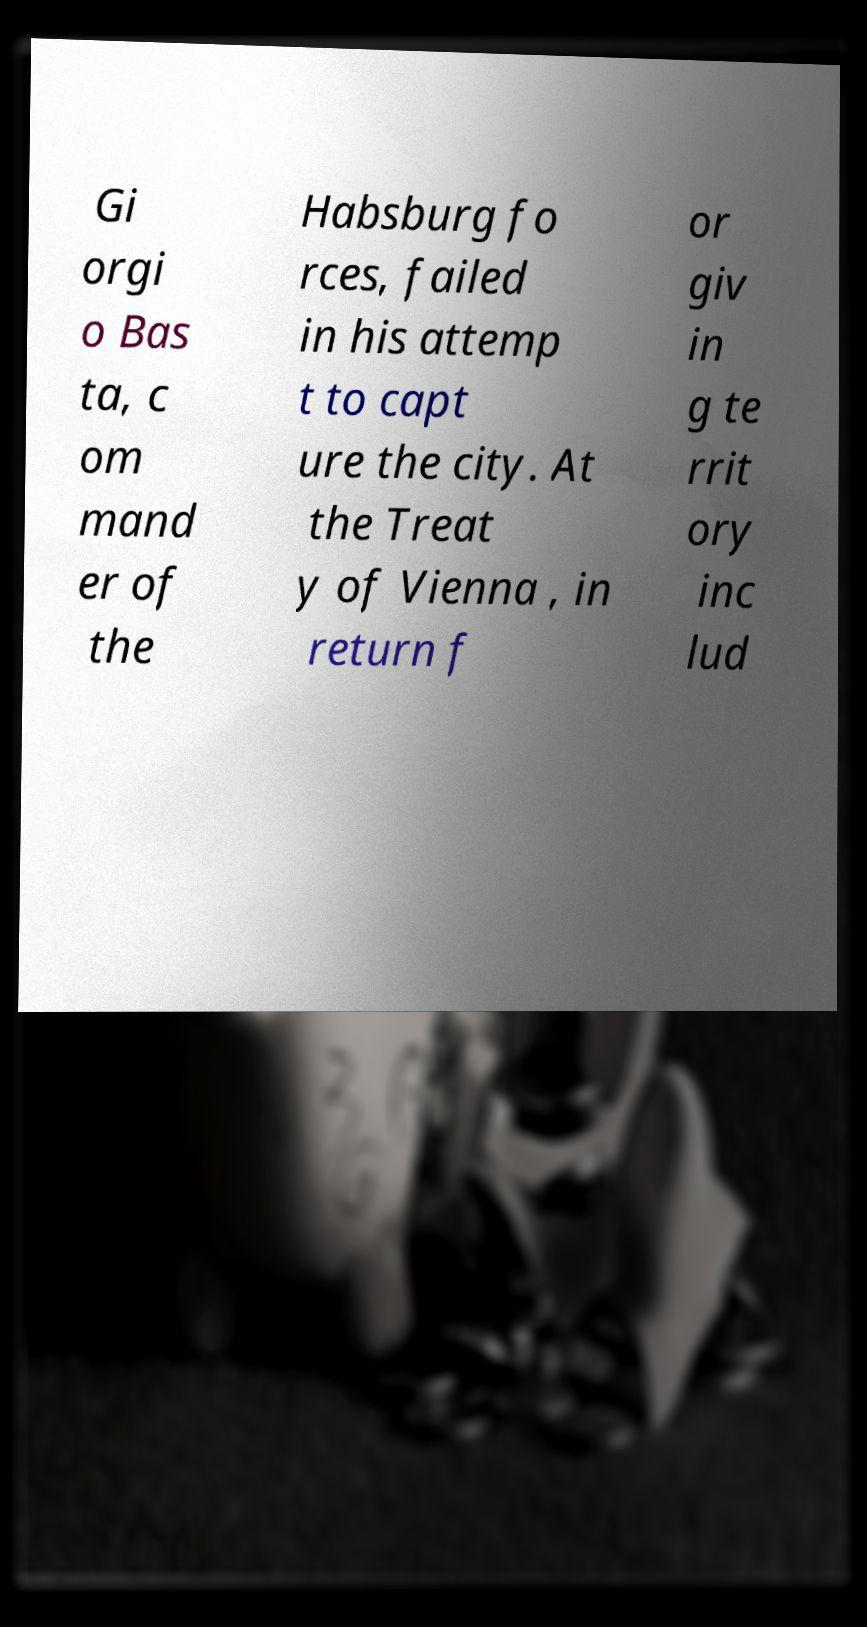Please read and relay the text visible in this image. What does it say? Gi orgi o Bas ta, c om mand er of the Habsburg fo rces, failed in his attemp t to capt ure the city. At the Treat y of Vienna , in return f or giv in g te rrit ory inc lud 